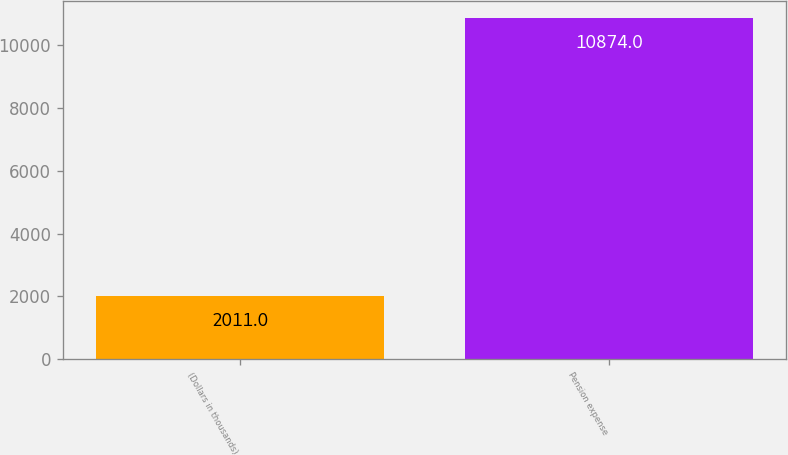Convert chart to OTSL. <chart><loc_0><loc_0><loc_500><loc_500><bar_chart><fcel>(Dollars in thousands)<fcel>Pension expense<nl><fcel>2011<fcel>10874<nl></chart> 